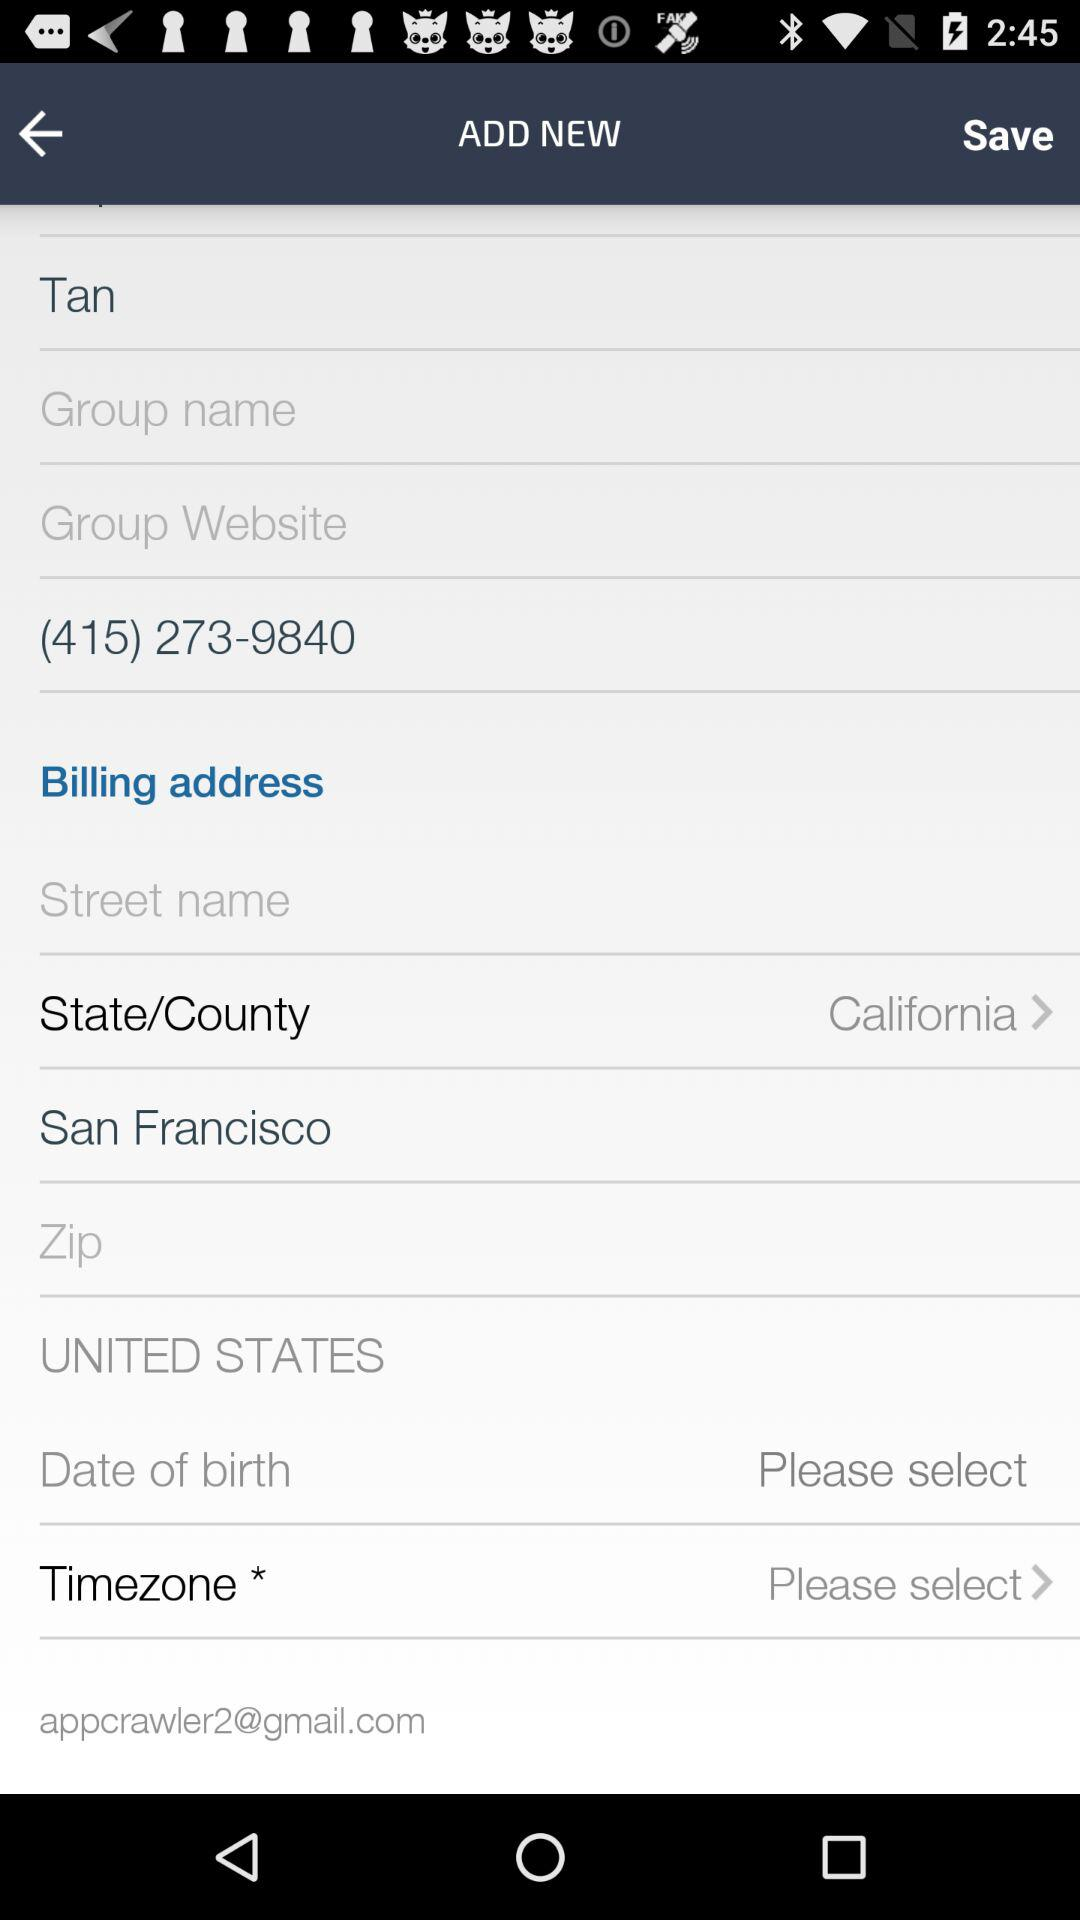What is the contact number? The contact number is (415) 273-9840. 